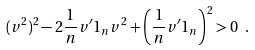Convert formula to latex. <formula><loc_0><loc_0><loc_500><loc_500>( v ^ { 2 } ) ^ { 2 } - 2 \frac { 1 } { n } v ^ { \prime } 1 _ { n } v ^ { 2 } + \left ( \frac { 1 } { n } v ^ { \prime } 1 _ { n } \right ) ^ { 2 } > 0 \ .</formula> 